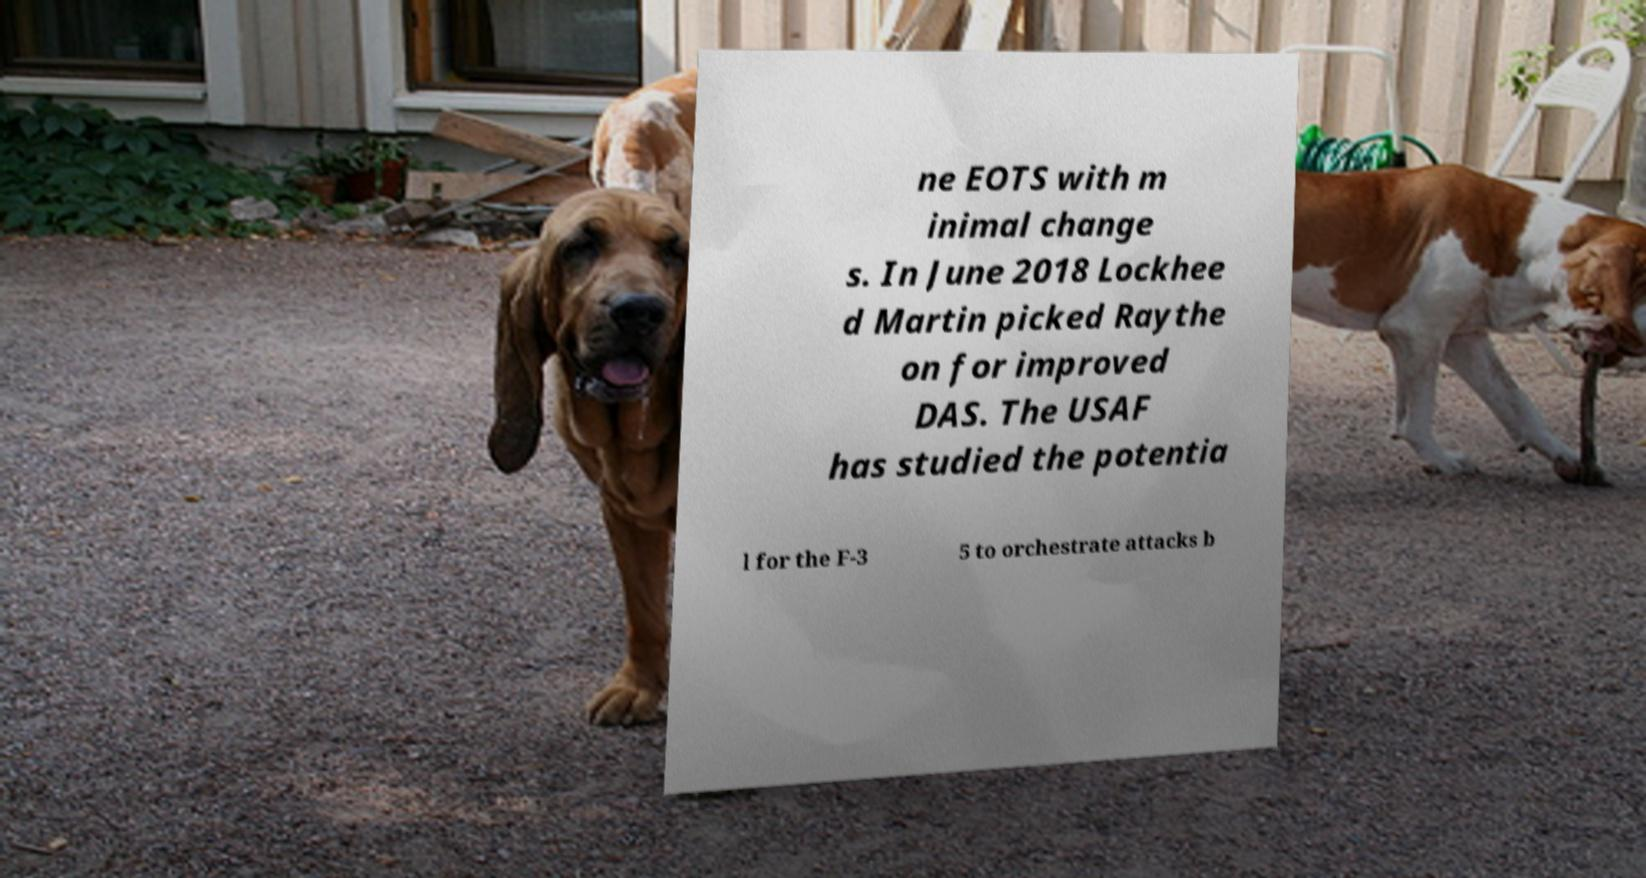Please read and relay the text visible in this image. What does it say? ne EOTS with m inimal change s. In June 2018 Lockhee d Martin picked Raythe on for improved DAS. The USAF has studied the potentia l for the F-3 5 to orchestrate attacks b 